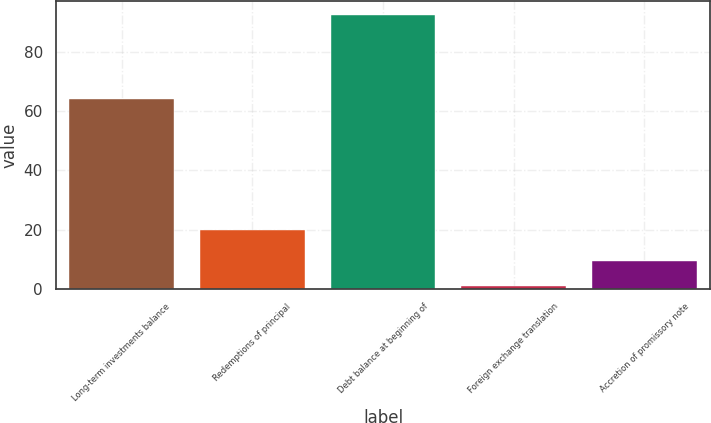Convert chart to OTSL. <chart><loc_0><loc_0><loc_500><loc_500><bar_chart><fcel>Long-term investments balance<fcel>Redemptions of principal<fcel>Debt balance at beginning of<fcel>Foreign exchange translation<fcel>Accretion of promissory note<nl><fcel>64<fcel>20<fcel>92.4<fcel>1<fcel>9.4<nl></chart> 